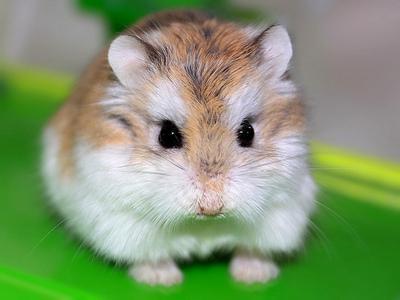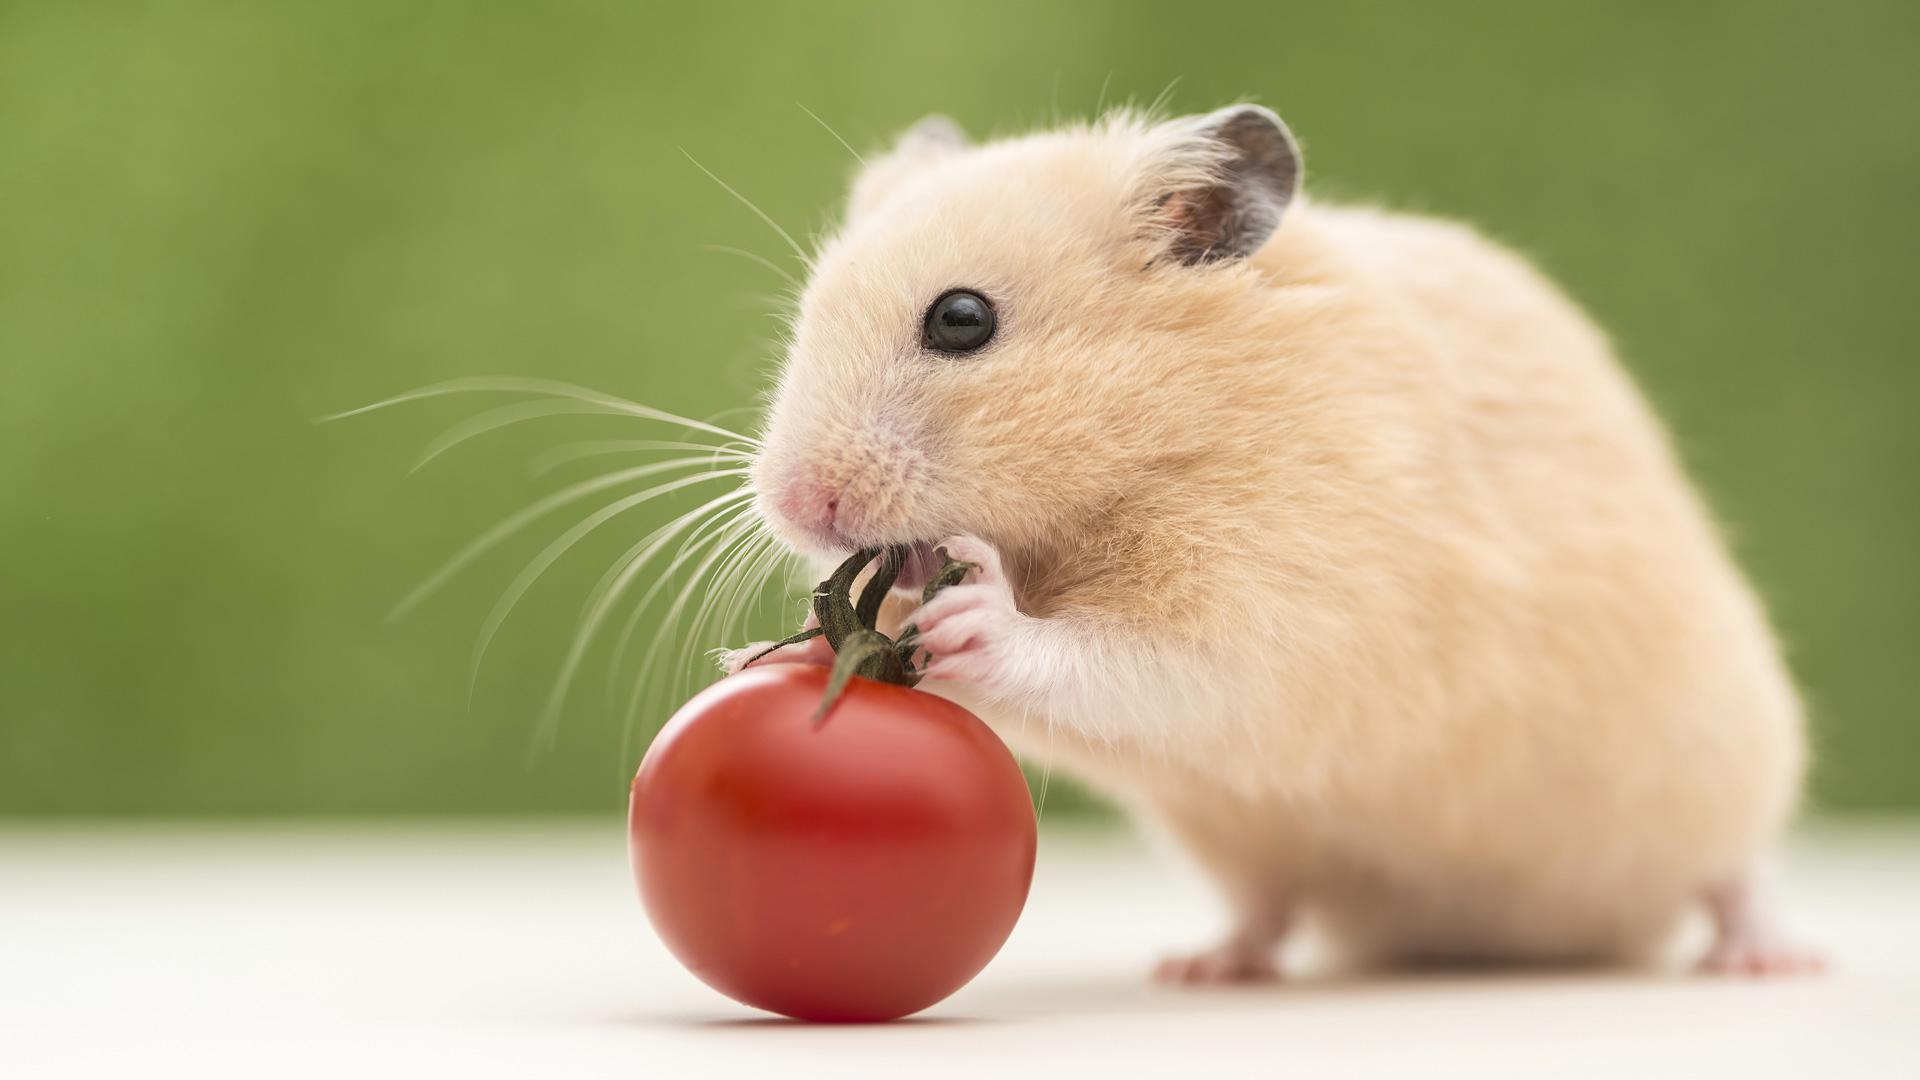The first image is the image on the left, the second image is the image on the right. For the images displayed, is the sentence "One of the animals is sitting on a rock." factually correct? Answer yes or no. No. 